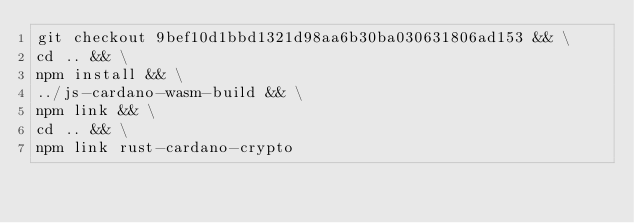Convert code to text. <code><loc_0><loc_0><loc_500><loc_500><_Bash_>git checkout 9bef10d1bbd1321d98aa6b30ba030631806ad153 && \
cd .. && \
npm install && \
../js-cardano-wasm-build && \
npm link && \
cd .. && \
npm link rust-cardano-crypto
</code> 